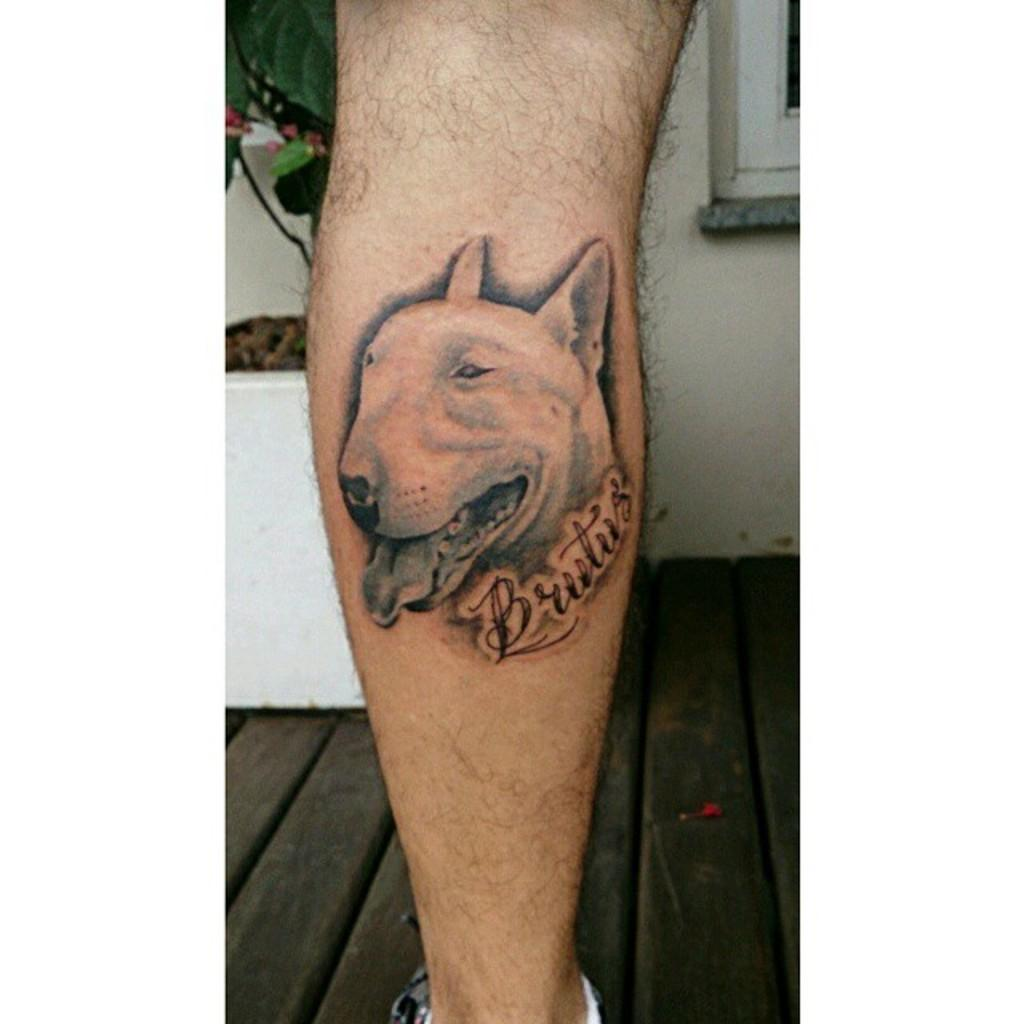What is depicted as a tattoo on the person's hand in the image? There is a tattoo of a dog on a person's hand in the image. What can be seen in the background of the image? There is a plant and a wall in the background of the image. How many girls are holding chalk in the image? There are no girls or chalk present in the image. What type of twig can be seen in the person's hand? There is no twig present in the image; the person's hand has a tattoo of a dog. 